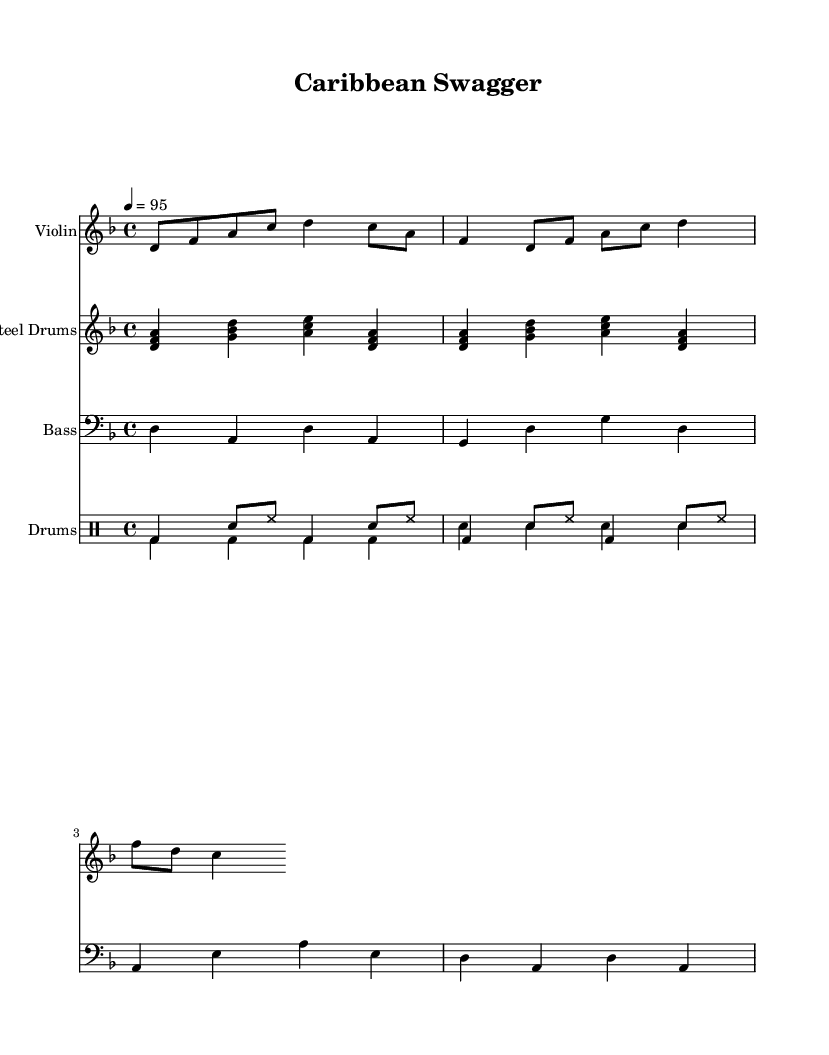What is the key signature of this music? The key signature is D minor, which has one flat (B flat). This can be identified as the key is specified at the beginning of the score.
Answer: D minor What is the time signature of the piece? The time signature is 4/4, meaning there are four beats in each measure. This is indicated at the beginning of the score.
Answer: 4/4 What is the tempo marking? The tempo marking is quarter note equals 95, which indicates the speed at which the piece should be played. This is also found at the beginning of the score.
Answer: 95 How many measures does the violin part contain? The violin part contains two measures, which can be counted from the patterned notes written for the violin.
Answer: 2 measures What instruments are featured in this piece? The instruments featured in this piece are Violin, Steel Drums, Bass, and Drums. This is indicated by the distinct instrumental lines at the beginning of the score.
Answer: Violin, Steel Drums, Bass, Drums What type of drums are used in this piece? The type of drums indicated in the score are bass drums and snare drums. This can be derived from the drummode notation present in the score.
Answer: Bass drums and snare drums What rhythmic pattern is primarily used in the drums? The rhythmic pattern used in the drums consists of bass drum hits followed by snare and hi-hat accents, creating a specific groove characteristic of hip hop. This can be identified by analyzing the drummode notation.
Answer: Bass and snare pattern 